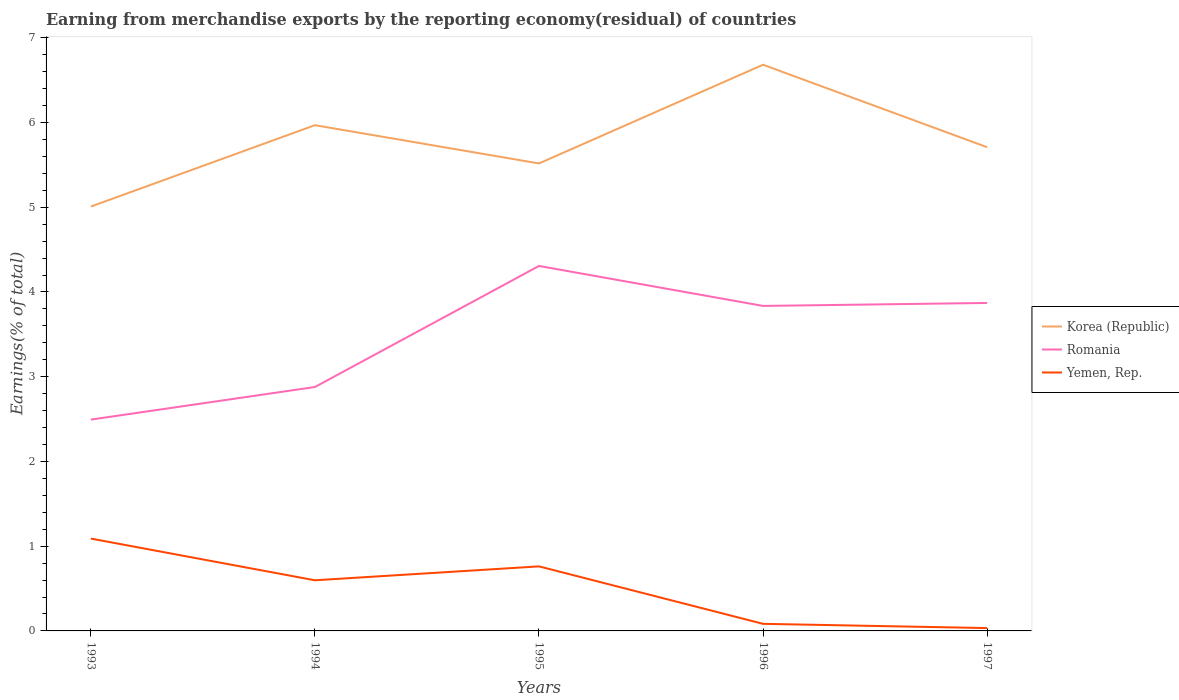Does the line corresponding to Korea (Republic) intersect with the line corresponding to Yemen, Rep.?
Offer a very short reply. No. Is the number of lines equal to the number of legend labels?
Keep it short and to the point. Yes. Across all years, what is the maximum percentage of amount earned from merchandise exports in Romania?
Offer a very short reply. 2.49. What is the total percentage of amount earned from merchandise exports in Romania in the graph?
Give a very brief answer. -1.34. What is the difference between the highest and the second highest percentage of amount earned from merchandise exports in Yemen, Rep.?
Offer a terse response. 1.06. Is the percentage of amount earned from merchandise exports in Romania strictly greater than the percentage of amount earned from merchandise exports in Korea (Republic) over the years?
Offer a terse response. Yes. How many years are there in the graph?
Provide a short and direct response. 5. Are the values on the major ticks of Y-axis written in scientific E-notation?
Make the answer very short. No. How many legend labels are there?
Your answer should be compact. 3. What is the title of the graph?
Offer a terse response. Earning from merchandise exports by the reporting economy(residual) of countries. What is the label or title of the X-axis?
Provide a short and direct response. Years. What is the label or title of the Y-axis?
Offer a terse response. Earnings(% of total). What is the Earnings(% of total) of Korea (Republic) in 1993?
Provide a succinct answer. 5.01. What is the Earnings(% of total) of Romania in 1993?
Offer a very short reply. 2.49. What is the Earnings(% of total) in Yemen, Rep. in 1993?
Make the answer very short. 1.09. What is the Earnings(% of total) of Korea (Republic) in 1994?
Keep it short and to the point. 5.97. What is the Earnings(% of total) of Romania in 1994?
Offer a very short reply. 2.88. What is the Earnings(% of total) of Yemen, Rep. in 1994?
Provide a succinct answer. 0.6. What is the Earnings(% of total) in Korea (Republic) in 1995?
Your answer should be compact. 5.52. What is the Earnings(% of total) of Romania in 1995?
Offer a very short reply. 4.31. What is the Earnings(% of total) in Yemen, Rep. in 1995?
Your answer should be very brief. 0.76. What is the Earnings(% of total) in Korea (Republic) in 1996?
Keep it short and to the point. 6.68. What is the Earnings(% of total) in Romania in 1996?
Your answer should be compact. 3.84. What is the Earnings(% of total) in Yemen, Rep. in 1996?
Your answer should be compact. 0.08. What is the Earnings(% of total) in Korea (Republic) in 1997?
Your answer should be very brief. 5.71. What is the Earnings(% of total) in Romania in 1997?
Offer a very short reply. 3.87. What is the Earnings(% of total) of Yemen, Rep. in 1997?
Make the answer very short. 0.03. Across all years, what is the maximum Earnings(% of total) in Korea (Republic)?
Your answer should be very brief. 6.68. Across all years, what is the maximum Earnings(% of total) of Romania?
Your answer should be compact. 4.31. Across all years, what is the maximum Earnings(% of total) of Yemen, Rep.?
Your answer should be compact. 1.09. Across all years, what is the minimum Earnings(% of total) in Korea (Republic)?
Ensure brevity in your answer.  5.01. Across all years, what is the minimum Earnings(% of total) in Romania?
Provide a succinct answer. 2.49. Across all years, what is the minimum Earnings(% of total) in Yemen, Rep.?
Ensure brevity in your answer.  0.03. What is the total Earnings(% of total) in Korea (Republic) in the graph?
Your response must be concise. 28.88. What is the total Earnings(% of total) of Romania in the graph?
Make the answer very short. 17.39. What is the total Earnings(% of total) in Yemen, Rep. in the graph?
Make the answer very short. 2.57. What is the difference between the Earnings(% of total) in Korea (Republic) in 1993 and that in 1994?
Offer a terse response. -0.96. What is the difference between the Earnings(% of total) in Romania in 1993 and that in 1994?
Offer a terse response. -0.38. What is the difference between the Earnings(% of total) in Yemen, Rep. in 1993 and that in 1994?
Give a very brief answer. 0.49. What is the difference between the Earnings(% of total) in Korea (Republic) in 1993 and that in 1995?
Provide a short and direct response. -0.51. What is the difference between the Earnings(% of total) of Romania in 1993 and that in 1995?
Offer a very short reply. -1.81. What is the difference between the Earnings(% of total) of Yemen, Rep. in 1993 and that in 1995?
Your response must be concise. 0.33. What is the difference between the Earnings(% of total) of Korea (Republic) in 1993 and that in 1996?
Provide a short and direct response. -1.67. What is the difference between the Earnings(% of total) in Romania in 1993 and that in 1996?
Give a very brief answer. -1.34. What is the difference between the Earnings(% of total) in Yemen, Rep. in 1993 and that in 1996?
Provide a succinct answer. 1.01. What is the difference between the Earnings(% of total) of Korea (Republic) in 1993 and that in 1997?
Provide a short and direct response. -0.7. What is the difference between the Earnings(% of total) of Romania in 1993 and that in 1997?
Keep it short and to the point. -1.38. What is the difference between the Earnings(% of total) in Yemen, Rep. in 1993 and that in 1997?
Give a very brief answer. 1.06. What is the difference between the Earnings(% of total) of Korea (Republic) in 1994 and that in 1995?
Offer a terse response. 0.45. What is the difference between the Earnings(% of total) of Romania in 1994 and that in 1995?
Your answer should be very brief. -1.43. What is the difference between the Earnings(% of total) in Yemen, Rep. in 1994 and that in 1995?
Offer a very short reply. -0.16. What is the difference between the Earnings(% of total) of Korea (Republic) in 1994 and that in 1996?
Provide a succinct answer. -0.71. What is the difference between the Earnings(% of total) in Romania in 1994 and that in 1996?
Ensure brevity in your answer.  -0.96. What is the difference between the Earnings(% of total) of Yemen, Rep. in 1994 and that in 1996?
Keep it short and to the point. 0.51. What is the difference between the Earnings(% of total) of Korea (Republic) in 1994 and that in 1997?
Give a very brief answer. 0.26. What is the difference between the Earnings(% of total) in Romania in 1994 and that in 1997?
Keep it short and to the point. -0.99. What is the difference between the Earnings(% of total) in Yemen, Rep. in 1994 and that in 1997?
Your answer should be very brief. 0.56. What is the difference between the Earnings(% of total) of Korea (Republic) in 1995 and that in 1996?
Provide a succinct answer. -1.16. What is the difference between the Earnings(% of total) in Romania in 1995 and that in 1996?
Give a very brief answer. 0.47. What is the difference between the Earnings(% of total) of Yemen, Rep. in 1995 and that in 1996?
Your answer should be very brief. 0.68. What is the difference between the Earnings(% of total) of Korea (Republic) in 1995 and that in 1997?
Your answer should be very brief. -0.19. What is the difference between the Earnings(% of total) of Romania in 1995 and that in 1997?
Provide a succinct answer. 0.44. What is the difference between the Earnings(% of total) of Yemen, Rep. in 1995 and that in 1997?
Offer a very short reply. 0.73. What is the difference between the Earnings(% of total) in Korea (Republic) in 1996 and that in 1997?
Keep it short and to the point. 0.97. What is the difference between the Earnings(% of total) of Romania in 1996 and that in 1997?
Offer a very short reply. -0.04. What is the difference between the Earnings(% of total) of Yemen, Rep. in 1996 and that in 1997?
Give a very brief answer. 0.05. What is the difference between the Earnings(% of total) of Korea (Republic) in 1993 and the Earnings(% of total) of Romania in 1994?
Provide a succinct answer. 2.13. What is the difference between the Earnings(% of total) of Korea (Republic) in 1993 and the Earnings(% of total) of Yemen, Rep. in 1994?
Keep it short and to the point. 4.41. What is the difference between the Earnings(% of total) of Romania in 1993 and the Earnings(% of total) of Yemen, Rep. in 1994?
Provide a succinct answer. 1.9. What is the difference between the Earnings(% of total) in Korea (Republic) in 1993 and the Earnings(% of total) in Romania in 1995?
Keep it short and to the point. 0.7. What is the difference between the Earnings(% of total) of Korea (Republic) in 1993 and the Earnings(% of total) of Yemen, Rep. in 1995?
Your response must be concise. 4.25. What is the difference between the Earnings(% of total) in Romania in 1993 and the Earnings(% of total) in Yemen, Rep. in 1995?
Your response must be concise. 1.73. What is the difference between the Earnings(% of total) in Korea (Republic) in 1993 and the Earnings(% of total) in Romania in 1996?
Make the answer very short. 1.17. What is the difference between the Earnings(% of total) of Korea (Republic) in 1993 and the Earnings(% of total) of Yemen, Rep. in 1996?
Offer a terse response. 4.92. What is the difference between the Earnings(% of total) of Romania in 1993 and the Earnings(% of total) of Yemen, Rep. in 1996?
Your answer should be very brief. 2.41. What is the difference between the Earnings(% of total) of Korea (Republic) in 1993 and the Earnings(% of total) of Romania in 1997?
Offer a terse response. 1.14. What is the difference between the Earnings(% of total) in Korea (Republic) in 1993 and the Earnings(% of total) in Yemen, Rep. in 1997?
Give a very brief answer. 4.97. What is the difference between the Earnings(% of total) in Romania in 1993 and the Earnings(% of total) in Yemen, Rep. in 1997?
Give a very brief answer. 2.46. What is the difference between the Earnings(% of total) in Korea (Republic) in 1994 and the Earnings(% of total) in Romania in 1995?
Keep it short and to the point. 1.66. What is the difference between the Earnings(% of total) of Korea (Republic) in 1994 and the Earnings(% of total) of Yemen, Rep. in 1995?
Provide a short and direct response. 5.21. What is the difference between the Earnings(% of total) in Romania in 1994 and the Earnings(% of total) in Yemen, Rep. in 1995?
Ensure brevity in your answer.  2.12. What is the difference between the Earnings(% of total) of Korea (Republic) in 1994 and the Earnings(% of total) of Romania in 1996?
Your response must be concise. 2.13. What is the difference between the Earnings(% of total) in Korea (Republic) in 1994 and the Earnings(% of total) in Yemen, Rep. in 1996?
Make the answer very short. 5.88. What is the difference between the Earnings(% of total) of Romania in 1994 and the Earnings(% of total) of Yemen, Rep. in 1996?
Your response must be concise. 2.79. What is the difference between the Earnings(% of total) in Korea (Republic) in 1994 and the Earnings(% of total) in Romania in 1997?
Give a very brief answer. 2.1. What is the difference between the Earnings(% of total) in Korea (Republic) in 1994 and the Earnings(% of total) in Yemen, Rep. in 1997?
Ensure brevity in your answer.  5.93. What is the difference between the Earnings(% of total) of Romania in 1994 and the Earnings(% of total) of Yemen, Rep. in 1997?
Your response must be concise. 2.84. What is the difference between the Earnings(% of total) in Korea (Republic) in 1995 and the Earnings(% of total) in Romania in 1996?
Your response must be concise. 1.68. What is the difference between the Earnings(% of total) of Korea (Republic) in 1995 and the Earnings(% of total) of Yemen, Rep. in 1996?
Your response must be concise. 5.43. What is the difference between the Earnings(% of total) in Romania in 1995 and the Earnings(% of total) in Yemen, Rep. in 1996?
Give a very brief answer. 4.22. What is the difference between the Earnings(% of total) of Korea (Republic) in 1995 and the Earnings(% of total) of Romania in 1997?
Keep it short and to the point. 1.65. What is the difference between the Earnings(% of total) in Korea (Republic) in 1995 and the Earnings(% of total) in Yemen, Rep. in 1997?
Offer a terse response. 5.48. What is the difference between the Earnings(% of total) in Romania in 1995 and the Earnings(% of total) in Yemen, Rep. in 1997?
Offer a terse response. 4.27. What is the difference between the Earnings(% of total) of Korea (Republic) in 1996 and the Earnings(% of total) of Romania in 1997?
Keep it short and to the point. 2.81. What is the difference between the Earnings(% of total) in Korea (Republic) in 1996 and the Earnings(% of total) in Yemen, Rep. in 1997?
Give a very brief answer. 6.65. What is the difference between the Earnings(% of total) of Romania in 1996 and the Earnings(% of total) of Yemen, Rep. in 1997?
Provide a short and direct response. 3.8. What is the average Earnings(% of total) of Korea (Republic) per year?
Keep it short and to the point. 5.78. What is the average Earnings(% of total) in Romania per year?
Give a very brief answer. 3.48. What is the average Earnings(% of total) of Yemen, Rep. per year?
Your answer should be very brief. 0.51. In the year 1993, what is the difference between the Earnings(% of total) in Korea (Republic) and Earnings(% of total) in Romania?
Provide a succinct answer. 2.51. In the year 1993, what is the difference between the Earnings(% of total) in Korea (Republic) and Earnings(% of total) in Yemen, Rep.?
Keep it short and to the point. 3.92. In the year 1993, what is the difference between the Earnings(% of total) in Romania and Earnings(% of total) in Yemen, Rep.?
Provide a short and direct response. 1.4. In the year 1994, what is the difference between the Earnings(% of total) in Korea (Republic) and Earnings(% of total) in Romania?
Make the answer very short. 3.09. In the year 1994, what is the difference between the Earnings(% of total) in Korea (Republic) and Earnings(% of total) in Yemen, Rep.?
Keep it short and to the point. 5.37. In the year 1994, what is the difference between the Earnings(% of total) of Romania and Earnings(% of total) of Yemen, Rep.?
Make the answer very short. 2.28. In the year 1995, what is the difference between the Earnings(% of total) of Korea (Republic) and Earnings(% of total) of Romania?
Give a very brief answer. 1.21. In the year 1995, what is the difference between the Earnings(% of total) of Korea (Republic) and Earnings(% of total) of Yemen, Rep.?
Offer a terse response. 4.76. In the year 1995, what is the difference between the Earnings(% of total) in Romania and Earnings(% of total) in Yemen, Rep.?
Your answer should be very brief. 3.55. In the year 1996, what is the difference between the Earnings(% of total) of Korea (Republic) and Earnings(% of total) of Romania?
Your answer should be compact. 2.85. In the year 1996, what is the difference between the Earnings(% of total) of Korea (Republic) and Earnings(% of total) of Yemen, Rep.?
Provide a succinct answer. 6.6. In the year 1996, what is the difference between the Earnings(% of total) in Romania and Earnings(% of total) in Yemen, Rep.?
Ensure brevity in your answer.  3.75. In the year 1997, what is the difference between the Earnings(% of total) in Korea (Republic) and Earnings(% of total) in Romania?
Provide a short and direct response. 1.84. In the year 1997, what is the difference between the Earnings(% of total) of Korea (Republic) and Earnings(% of total) of Yemen, Rep.?
Make the answer very short. 5.67. In the year 1997, what is the difference between the Earnings(% of total) in Romania and Earnings(% of total) in Yemen, Rep.?
Offer a terse response. 3.84. What is the ratio of the Earnings(% of total) in Korea (Republic) in 1993 to that in 1994?
Your response must be concise. 0.84. What is the ratio of the Earnings(% of total) in Romania in 1993 to that in 1994?
Keep it short and to the point. 0.87. What is the ratio of the Earnings(% of total) of Yemen, Rep. in 1993 to that in 1994?
Provide a short and direct response. 1.82. What is the ratio of the Earnings(% of total) of Korea (Republic) in 1993 to that in 1995?
Provide a succinct answer. 0.91. What is the ratio of the Earnings(% of total) in Romania in 1993 to that in 1995?
Your response must be concise. 0.58. What is the ratio of the Earnings(% of total) in Yemen, Rep. in 1993 to that in 1995?
Ensure brevity in your answer.  1.43. What is the ratio of the Earnings(% of total) in Korea (Republic) in 1993 to that in 1996?
Offer a terse response. 0.75. What is the ratio of the Earnings(% of total) of Romania in 1993 to that in 1996?
Your response must be concise. 0.65. What is the ratio of the Earnings(% of total) in Yemen, Rep. in 1993 to that in 1996?
Offer a very short reply. 13.02. What is the ratio of the Earnings(% of total) in Korea (Republic) in 1993 to that in 1997?
Provide a short and direct response. 0.88. What is the ratio of the Earnings(% of total) in Romania in 1993 to that in 1997?
Ensure brevity in your answer.  0.64. What is the ratio of the Earnings(% of total) of Yemen, Rep. in 1993 to that in 1997?
Your response must be concise. 32.45. What is the ratio of the Earnings(% of total) of Korea (Republic) in 1994 to that in 1995?
Offer a very short reply. 1.08. What is the ratio of the Earnings(% of total) in Romania in 1994 to that in 1995?
Give a very brief answer. 0.67. What is the ratio of the Earnings(% of total) of Yemen, Rep. in 1994 to that in 1995?
Make the answer very short. 0.78. What is the ratio of the Earnings(% of total) in Korea (Republic) in 1994 to that in 1996?
Ensure brevity in your answer.  0.89. What is the ratio of the Earnings(% of total) in Romania in 1994 to that in 1996?
Give a very brief answer. 0.75. What is the ratio of the Earnings(% of total) in Yemen, Rep. in 1994 to that in 1996?
Make the answer very short. 7.14. What is the ratio of the Earnings(% of total) in Korea (Republic) in 1994 to that in 1997?
Offer a terse response. 1.05. What is the ratio of the Earnings(% of total) in Romania in 1994 to that in 1997?
Ensure brevity in your answer.  0.74. What is the ratio of the Earnings(% of total) of Yemen, Rep. in 1994 to that in 1997?
Your answer should be very brief. 17.8. What is the ratio of the Earnings(% of total) in Korea (Republic) in 1995 to that in 1996?
Your answer should be very brief. 0.83. What is the ratio of the Earnings(% of total) in Romania in 1995 to that in 1996?
Ensure brevity in your answer.  1.12. What is the ratio of the Earnings(% of total) in Yemen, Rep. in 1995 to that in 1996?
Ensure brevity in your answer.  9.1. What is the ratio of the Earnings(% of total) in Korea (Republic) in 1995 to that in 1997?
Provide a succinct answer. 0.97. What is the ratio of the Earnings(% of total) in Romania in 1995 to that in 1997?
Make the answer very short. 1.11. What is the ratio of the Earnings(% of total) in Yemen, Rep. in 1995 to that in 1997?
Give a very brief answer. 22.68. What is the ratio of the Earnings(% of total) of Korea (Republic) in 1996 to that in 1997?
Offer a very short reply. 1.17. What is the ratio of the Earnings(% of total) in Yemen, Rep. in 1996 to that in 1997?
Your answer should be compact. 2.49. What is the difference between the highest and the second highest Earnings(% of total) in Korea (Republic)?
Keep it short and to the point. 0.71. What is the difference between the highest and the second highest Earnings(% of total) in Romania?
Make the answer very short. 0.44. What is the difference between the highest and the second highest Earnings(% of total) in Yemen, Rep.?
Your answer should be very brief. 0.33. What is the difference between the highest and the lowest Earnings(% of total) of Korea (Republic)?
Provide a succinct answer. 1.67. What is the difference between the highest and the lowest Earnings(% of total) of Romania?
Your answer should be very brief. 1.81. What is the difference between the highest and the lowest Earnings(% of total) in Yemen, Rep.?
Provide a succinct answer. 1.06. 